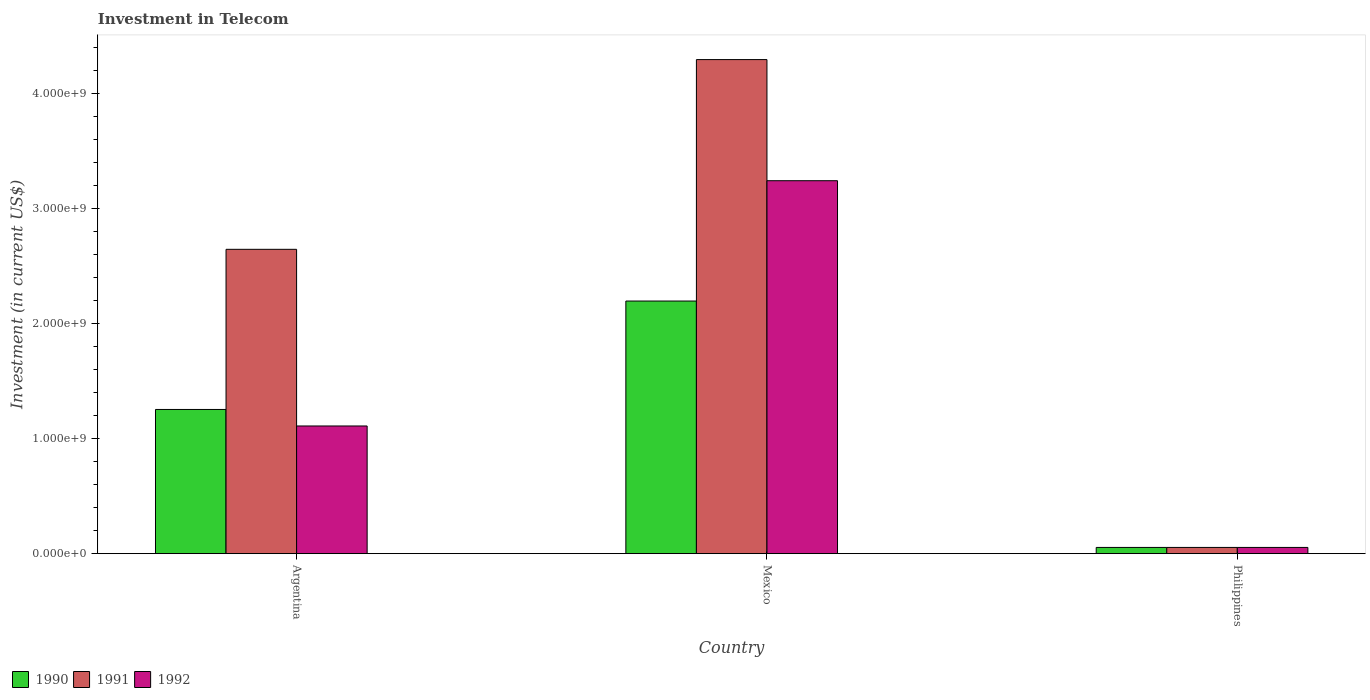Are the number of bars per tick equal to the number of legend labels?
Your response must be concise. Yes. Are the number of bars on each tick of the X-axis equal?
Ensure brevity in your answer.  Yes. How many bars are there on the 2nd tick from the right?
Give a very brief answer. 3. What is the label of the 1st group of bars from the left?
Keep it short and to the point. Argentina. In how many cases, is the number of bars for a given country not equal to the number of legend labels?
Ensure brevity in your answer.  0. What is the amount invested in telecom in 1990 in Philippines?
Your answer should be compact. 5.42e+07. Across all countries, what is the maximum amount invested in telecom in 1990?
Offer a terse response. 2.20e+09. Across all countries, what is the minimum amount invested in telecom in 1990?
Offer a terse response. 5.42e+07. What is the total amount invested in telecom in 1990 in the graph?
Your answer should be compact. 3.51e+09. What is the difference between the amount invested in telecom in 1990 in Mexico and that in Philippines?
Give a very brief answer. 2.14e+09. What is the difference between the amount invested in telecom in 1991 in Mexico and the amount invested in telecom in 1990 in Argentina?
Keep it short and to the point. 3.04e+09. What is the average amount invested in telecom in 1991 per country?
Your answer should be compact. 2.33e+09. What is the difference between the amount invested in telecom of/in 1990 and amount invested in telecom of/in 1991 in Mexico?
Your response must be concise. -2.10e+09. What is the ratio of the amount invested in telecom in 1992 in Argentina to that in Mexico?
Make the answer very short. 0.34. What is the difference between the highest and the second highest amount invested in telecom in 1991?
Provide a succinct answer. 1.65e+09. What is the difference between the highest and the lowest amount invested in telecom in 1990?
Your answer should be very brief. 2.14e+09. What does the 2nd bar from the right in Argentina represents?
Provide a succinct answer. 1991. Is it the case that in every country, the sum of the amount invested in telecom in 1991 and amount invested in telecom in 1990 is greater than the amount invested in telecom in 1992?
Offer a very short reply. Yes. How many bars are there?
Your answer should be compact. 9. What is the difference between two consecutive major ticks on the Y-axis?
Your answer should be very brief. 1.00e+09. Does the graph contain any zero values?
Offer a terse response. No. How many legend labels are there?
Provide a short and direct response. 3. What is the title of the graph?
Ensure brevity in your answer.  Investment in Telecom. Does "1962" appear as one of the legend labels in the graph?
Your answer should be very brief. No. What is the label or title of the Y-axis?
Make the answer very short. Investment (in current US$). What is the Investment (in current US$) in 1990 in Argentina?
Your answer should be very brief. 1.25e+09. What is the Investment (in current US$) of 1991 in Argentina?
Keep it short and to the point. 2.65e+09. What is the Investment (in current US$) of 1992 in Argentina?
Provide a short and direct response. 1.11e+09. What is the Investment (in current US$) in 1990 in Mexico?
Provide a succinct answer. 2.20e+09. What is the Investment (in current US$) of 1991 in Mexico?
Offer a very short reply. 4.30e+09. What is the Investment (in current US$) of 1992 in Mexico?
Your answer should be compact. 3.24e+09. What is the Investment (in current US$) in 1990 in Philippines?
Provide a succinct answer. 5.42e+07. What is the Investment (in current US$) in 1991 in Philippines?
Provide a short and direct response. 5.42e+07. What is the Investment (in current US$) of 1992 in Philippines?
Offer a very short reply. 5.42e+07. Across all countries, what is the maximum Investment (in current US$) in 1990?
Provide a succinct answer. 2.20e+09. Across all countries, what is the maximum Investment (in current US$) in 1991?
Provide a succinct answer. 4.30e+09. Across all countries, what is the maximum Investment (in current US$) of 1992?
Your answer should be compact. 3.24e+09. Across all countries, what is the minimum Investment (in current US$) in 1990?
Offer a very short reply. 5.42e+07. Across all countries, what is the minimum Investment (in current US$) of 1991?
Offer a terse response. 5.42e+07. Across all countries, what is the minimum Investment (in current US$) of 1992?
Provide a short and direct response. 5.42e+07. What is the total Investment (in current US$) in 1990 in the graph?
Offer a very short reply. 3.51e+09. What is the total Investment (in current US$) of 1991 in the graph?
Your answer should be compact. 7.00e+09. What is the total Investment (in current US$) in 1992 in the graph?
Offer a very short reply. 4.41e+09. What is the difference between the Investment (in current US$) of 1990 in Argentina and that in Mexico?
Offer a terse response. -9.43e+08. What is the difference between the Investment (in current US$) of 1991 in Argentina and that in Mexico?
Your response must be concise. -1.65e+09. What is the difference between the Investment (in current US$) in 1992 in Argentina and that in Mexico?
Keep it short and to the point. -2.13e+09. What is the difference between the Investment (in current US$) in 1990 in Argentina and that in Philippines?
Offer a terse response. 1.20e+09. What is the difference between the Investment (in current US$) of 1991 in Argentina and that in Philippines?
Your answer should be very brief. 2.59e+09. What is the difference between the Investment (in current US$) of 1992 in Argentina and that in Philippines?
Your answer should be very brief. 1.06e+09. What is the difference between the Investment (in current US$) of 1990 in Mexico and that in Philippines?
Provide a succinct answer. 2.14e+09. What is the difference between the Investment (in current US$) in 1991 in Mexico and that in Philippines?
Offer a terse response. 4.24e+09. What is the difference between the Investment (in current US$) in 1992 in Mexico and that in Philippines?
Provide a short and direct response. 3.19e+09. What is the difference between the Investment (in current US$) in 1990 in Argentina and the Investment (in current US$) in 1991 in Mexico?
Your response must be concise. -3.04e+09. What is the difference between the Investment (in current US$) in 1990 in Argentina and the Investment (in current US$) in 1992 in Mexico?
Give a very brief answer. -1.99e+09. What is the difference between the Investment (in current US$) of 1991 in Argentina and the Investment (in current US$) of 1992 in Mexico?
Give a very brief answer. -5.97e+08. What is the difference between the Investment (in current US$) of 1990 in Argentina and the Investment (in current US$) of 1991 in Philippines?
Offer a very short reply. 1.20e+09. What is the difference between the Investment (in current US$) of 1990 in Argentina and the Investment (in current US$) of 1992 in Philippines?
Offer a very short reply. 1.20e+09. What is the difference between the Investment (in current US$) of 1991 in Argentina and the Investment (in current US$) of 1992 in Philippines?
Ensure brevity in your answer.  2.59e+09. What is the difference between the Investment (in current US$) of 1990 in Mexico and the Investment (in current US$) of 1991 in Philippines?
Make the answer very short. 2.14e+09. What is the difference between the Investment (in current US$) in 1990 in Mexico and the Investment (in current US$) in 1992 in Philippines?
Your answer should be compact. 2.14e+09. What is the difference between the Investment (in current US$) of 1991 in Mexico and the Investment (in current US$) of 1992 in Philippines?
Keep it short and to the point. 4.24e+09. What is the average Investment (in current US$) in 1990 per country?
Ensure brevity in your answer.  1.17e+09. What is the average Investment (in current US$) in 1991 per country?
Offer a very short reply. 2.33e+09. What is the average Investment (in current US$) of 1992 per country?
Provide a short and direct response. 1.47e+09. What is the difference between the Investment (in current US$) in 1990 and Investment (in current US$) in 1991 in Argentina?
Your response must be concise. -1.39e+09. What is the difference between the Investment (in current US$) of 1990 and Investment (in current US$) of 1992 in Argentina?
Ensure brevity in your answer.  1.44e+08. What is the difference between the Investment (in current US$) in 1991 and Investment (in current US$) in 1992 in Argentina?
Your answer should be very brief. 1.54e+09. What is the difference between the Investment (in current US$) of 1990 and Investment (in current US$) of 1991 in Mexico?
Make the answer very short. -2.10e+09. What is the difference between the Investment (in current US$) in 1990 and Investment (in current US$) in 1992 in Mexico?
Give a very brief answer. -1.05e+09. What is the difference between the Investment (in current US$) in 1991 and Investment (in current US$) in 1992 in Mexico?
Keep it short and to the point. 1.05e+09. What is the difference between the Investment (in current US$) in 1991 and Investment (in current US$) in 1992 in Philippines?
Your response must be concise. 0. What is the ratio of the Investment (in current US$) in 1990 in Argentina to that in Mexico?
Keep it short and to the point. 0.57. What is the ratio of the Investment (in current US$) of 1991 in Argentina to that in Mexico?
Give a very brief answer. 0.62. What is the ratio of the Investment (in current US$) of 1992 in Argentina to that in Mexico?
Offer a very short reply. 0.34. What is the ratio of the Investment (in current US$) in 1990 in Argentina to that in Philippines?
Your answer should be very brief. 23.15. What is the ratio of the Investment (in current US$) of 1991 in Argentina to that in Philippines?
Ensure brevity in your answer.  48.86. What is the ratio of the Investment (in current US$) in 1992 in Argentina to that in Philippines?
Offer a terse response. 20.5. What is the ratio of the Investment (in current US$) of 1990 in Mexico to that in Philippines?
Your answer should be compact. 40.55. What is the ratio of the Investment (in current US$) of 1991 in Mexico to that in Philippines?
Your answer should be very brief. 79.32. What is the ratio of the Investment (in current US$) of 1992 in Mexico to that in Philippines?
Make the answer very short. 59.87. What is the difference between the highest and the second highest Investment (in current US$) in 1990?
Your response must be concise. 9.43e+08. What is the difference between the highest and the second highest Investment (in current US$) of 1991?
Your answer should be compact. 1.65e+09. What is the difference between the highest and the second highest Investment (in current US$) in 1992?
Your response must be concise. 2.13e+09. What is the difference between the highest and the lowest Investment (in current US$) of 1990?
Ensure brevity in your answer.  2.14e+09. What is the difference between the highest and the lowest Investment (in current US$) in 1991?
Keep it short and to the point. 4.24e+09. What is the difference between the highest and the lowest Investment (in current US$) of 1992?
Give a very brief answer. 3.19e+09. 